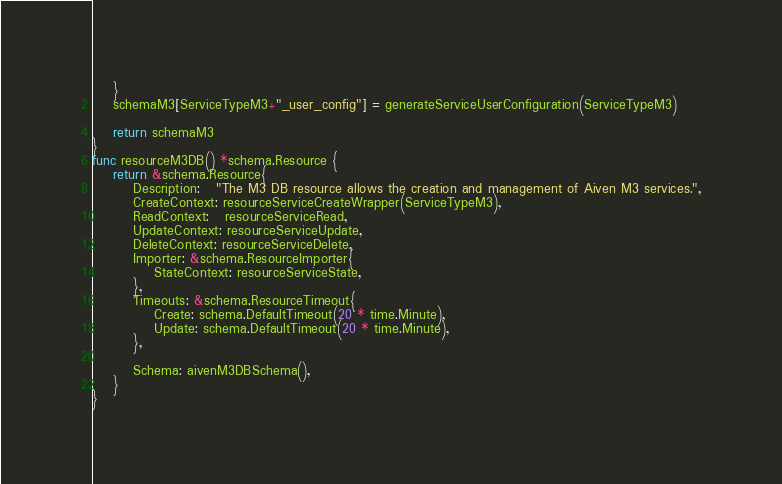Convert code to text. <code><loc_0><loc_0><loc_500><loc_500><_Go_>	}
	schemaM3[ServiceTypeM3+"_user_config"] = generateServiceUserConfiguration(ServiceTypeM3)

	return schemaM3
}
func resourceM3DB() *schema.Resource {
	return &schema.Resource{
		Description:   "The M3 DB resource allows the creation and management of Aiven M3 services.",
		CreateContext: resourceServiceCreateWrapper(ServiceTypeM3),
		ReadContext:   resourceServiceRead,
		UpdateContext: resourceServiceUpdate,
		DeleteContext: resourceServiceDelete,
		Importer: &schema.ResourceImporter{
			StateContext: resourceServiceState,
		},
		Timeouts: &schema.ResourceTimeout{
			Create: schema.DefaultTimeout(20 * time.Minute),
			Update: schema.DefaultTimeout(20 * time.Minute),
		},

		Schema: aivenM3DBSchema(),
	}
}
</code> 